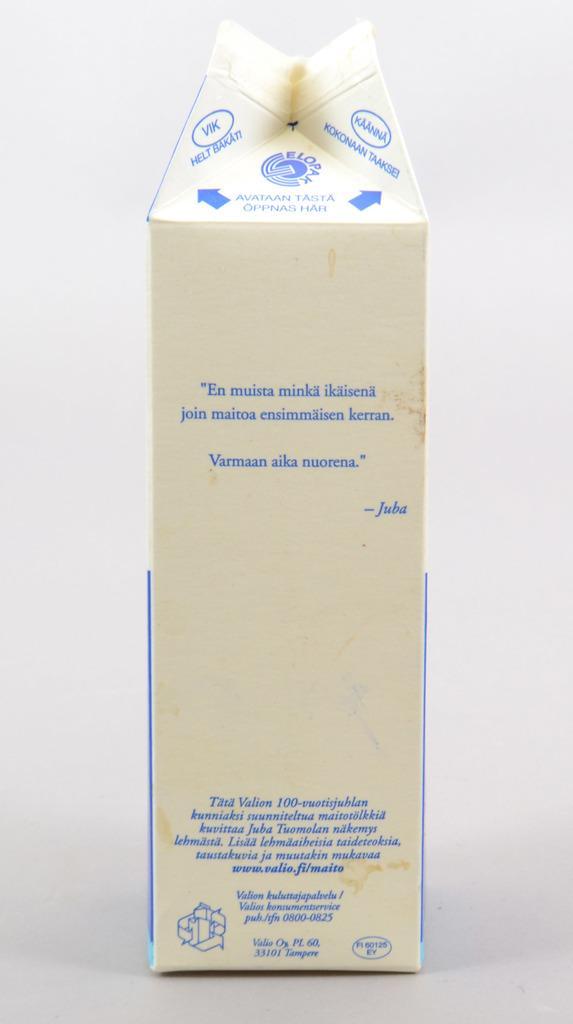Describe this image in one or two sentences. In the center of the image there is a carton. 